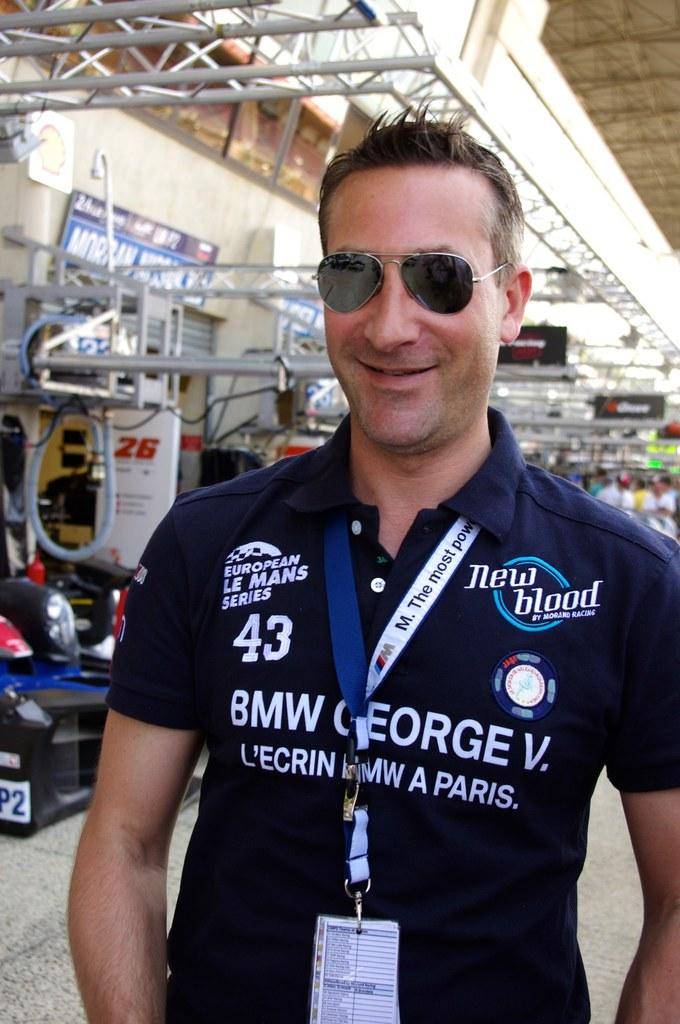What is the person in the image wearing? The person in the image is wearing a black dress. How is the person described in the image? The person is described as stunning. What can be seen in the background of the image? In the background of the image, there are metal rods, other persons, banners, the ceiling, and other unspecified objects. How many pigs are visible in the image? There are no pigs present in the image. What type of locket is the person wearing in the image? There is no locket visible on the person in the image. 